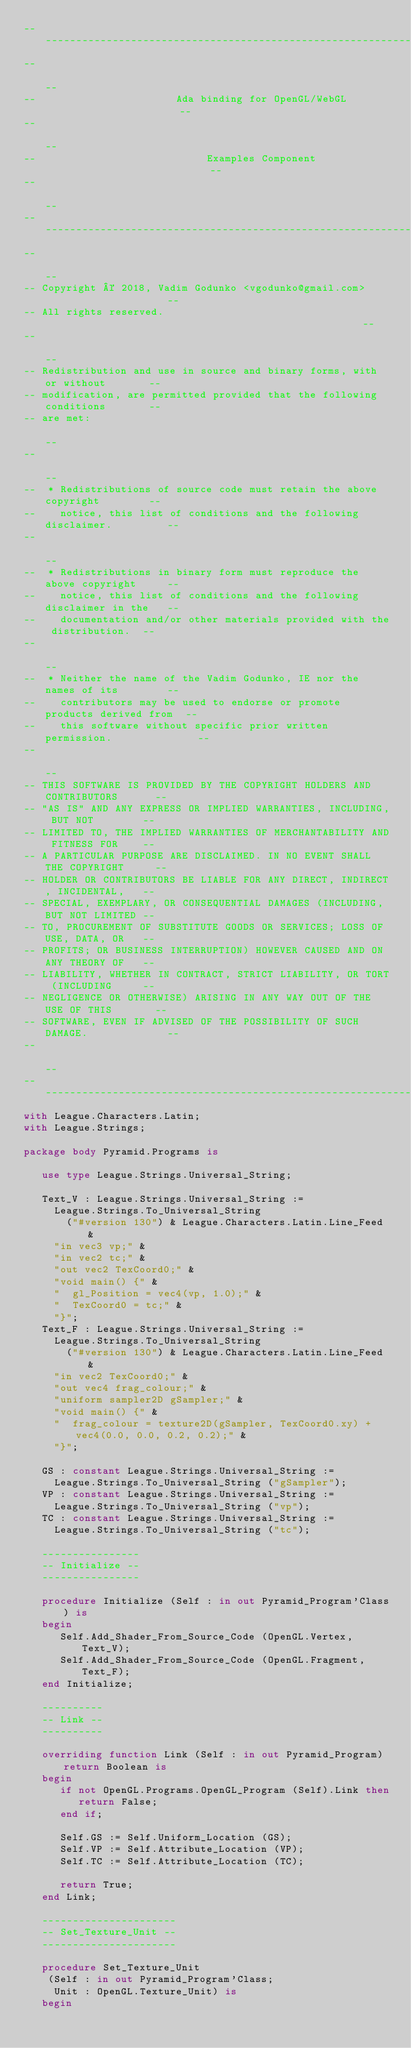<code> <loc_0><loc_0><loc_500><loc_500><_Ada_>------------------------------------------------------------------------------
--                                                                          --
--                       Ada binding for OpenGL/WebGL                       --
--                                                                          --
--                            Examples Component                            --
--                                                                          --
------------------------------------------------------------------------------
--                                                                          --
-- Copyright © 2018, Vadim Godunko <vgodunko@gmail.com>                     --
-- All rights reserved.                                                     --
--                                                                          --
-- Redistribution and use in source and binary forms, with or without       --
-- modification, are permitted provided that the following conditions       --
-- are met:                                                                 --
--                                                                          --
--  * Redistributions of source code must retain the above copyright        --
--    notice, this list of conditions and the following disclaimer.         --
--                                                                          --
--  * Redistributions in binary form must reproduce the above copyright     --
--    notice, this list of conditions and the following disclaimer in the   --
--    documentation and/or other materials provided with the distribution.  --
--                                                                          --
--  * Neither the name of the Vadim Godunko, IE nor the names of its        --
--    contributors may be used to endorse or promote products derived from  --
--    this software without specific prior written permission.              --
--                                                                          --
-- THIS SOFTWARE IS PROVIDED BY THE COPYRIGHT HOLDERS AND CONTRIBUTORS      --
-- "AS IS" AND ANY EXPRESS OR IMPLIED WARRANTIES, INCLUDING, BUT NOT        --
-- LIMITED TO, THE IMPLIED WARRANTIES OF MERCHANTABILITY AND FITNESS FOR    --
-- A PARTICULAR PURPOSE ARE DISCLAIMED. IN NO EVENT SHALL THE COPYRIGHT     --
-- HOLDER OR CONTRIBUTORS BE LIABLE FOR ANY DIRECT, INDIRECT, INCIDENTAL,   --
-- SPECIAL, EXEMPLARY, OR CONSEQUENTIAL DAMAGES (INCLUDING, BUT NOT LIMITED --
-- TO, PROCUREMENT OF SUBSTITUTE GOODS OR SERVICES; LOSS OF USE, DATA, OR   --
-- PROFITS; OR BUSINESS INTERRUPTION) HOWEVER CAUSED AND ON ANY THEORY OF   --
-- LIABILITY, WHETHER IN CONTRACT, STRICT LIABILITY, OR TORT (INCLUDING     --
-- NEGLIGENCE OR OTHERWISE) ARISING IN ANY WAY OUT OF THE USE OF THIS       --
-- SOFTWARE, EVEN IF ADVISED OF THE POSSIBILITY OF SUCH DAMAGE.             --
--                                                                          --
------------------------------------------------------------------------------
with League.Characters.Latin;
with League.Strings;

package body Pyramid.Programs is

   use type League.Strings.Universal_String;

   Text_V : League.Strings.Universal_String :=
     League.Strings.To_Universal_String
       ("#version 130") & League.Characters.Latin.Line_Feed &
     "in vec3 vp;" &
     "in vec2 tc;" &
     "out vec2 TexCoord0;" &
     "void main() {" &
     "  gl_Position = vec4(vp, 1.0);" &
     "  TexCoord0 = tc;" &
     "}";
   Text_F : League.Strings.Universal_String :=
     League.Strings.To_Universal_String
       ("#version 130") & League.Characters.Latin.Line_Feed &
     "in vec2 TexCoord0;" &
     "out vec4 frag_colour;" &
     "uniform sampler2D gSampler;" &
     "void main() {" &
     "  frag_colour = texture2D(gSampler, TexCoord0.xy) +vec4(0.0, 0.0, 0.2, 0.2);" &
     "}";

   GS : constant League.Strings.Universal_String :=
     League.Strings.To_Universal_String ("gSampler");
   VP : constant League.Strings.Universal_String :=
     League.Strings.To_Universal_String ("vp");
   TC : constant League.Strings.Universal_String :=
     League.Strings.To_Universal_String ("tc");

   ----------------
   -- Initialize --
   ----------------

   procedure Initialize (Self : in out Pyramid_Program'Class) is
   begin
      Self.Add_Shader_From_Source_Code (OpenGL.Vertex, Text_V);
      Self.Add_Shader_From_Source_Code (OpenGL.Fragment, Text_F);
   end Initialize;

   ----------
   -- Link --
   ----------

   overriding function Link (Self : in out Pyramid_Program) return Boolean is
   begin
      if not OpenGL.Programs.OpenGL_Program (Self).Link then
         return False;
      end if;

      Self.GS := Self.Uniform_Location (GS);
      Self.VP := Self.Attribute_Location (VP);
      Self.TC := Self.Attribute_Location (TC);

      return True;
   end Link;

   ----------------------
   -- Set_Texture_Unit --
   ----------------------

   procedure Set_Texture_Unit
    (Self : in out Pyramid_Program'Class;
     Unit : OpenGL.Texture_Unit) is
   begin</code> 